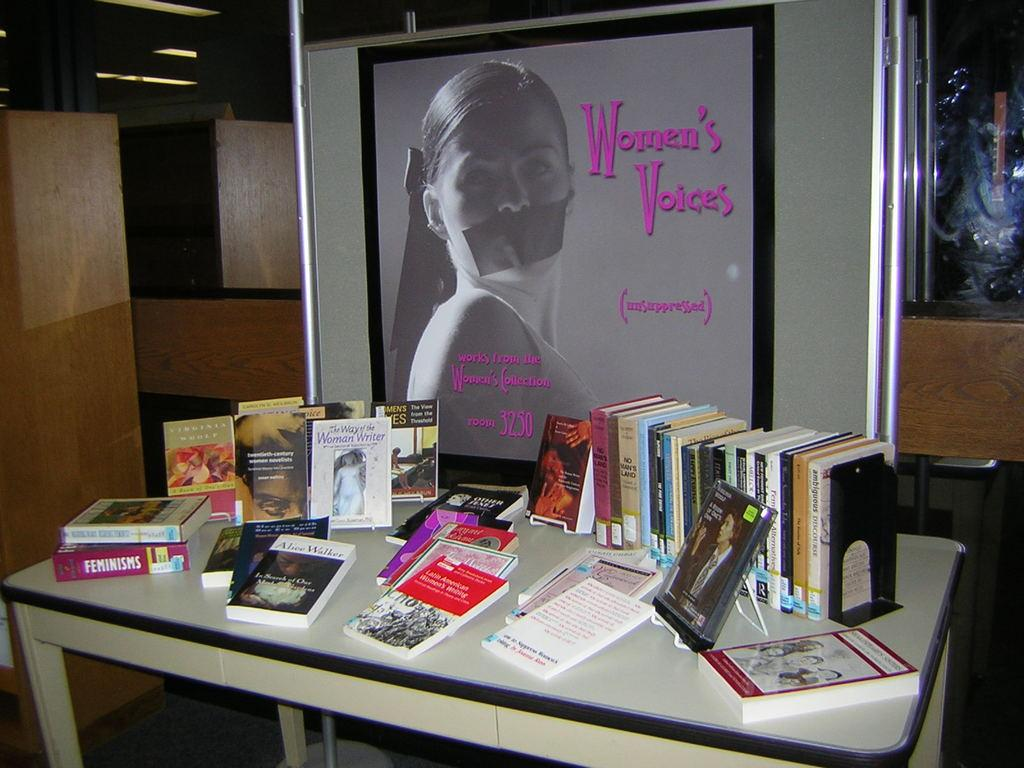<image>
Create a compact narrative representing the image presented. A number of feminist books sit on a table below a poster showing a woman with tape over her mouth and the words womens voices. 